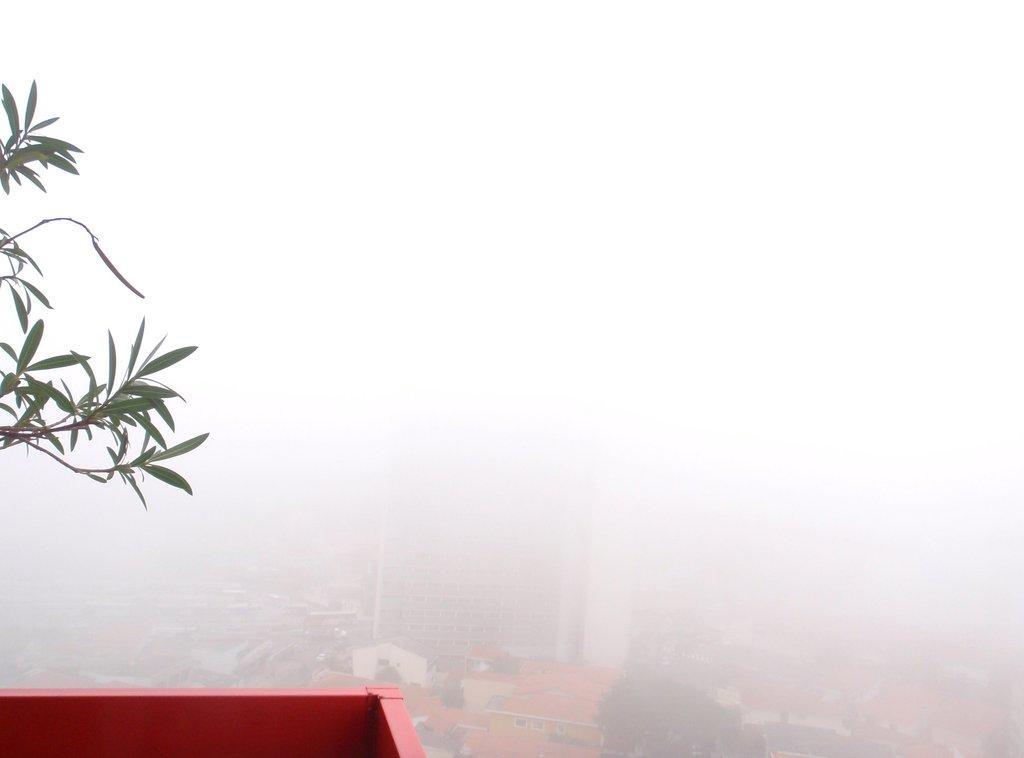Describe this image in one or two sentences. In the image we can see the leaves and buildings, and smoky sky. 